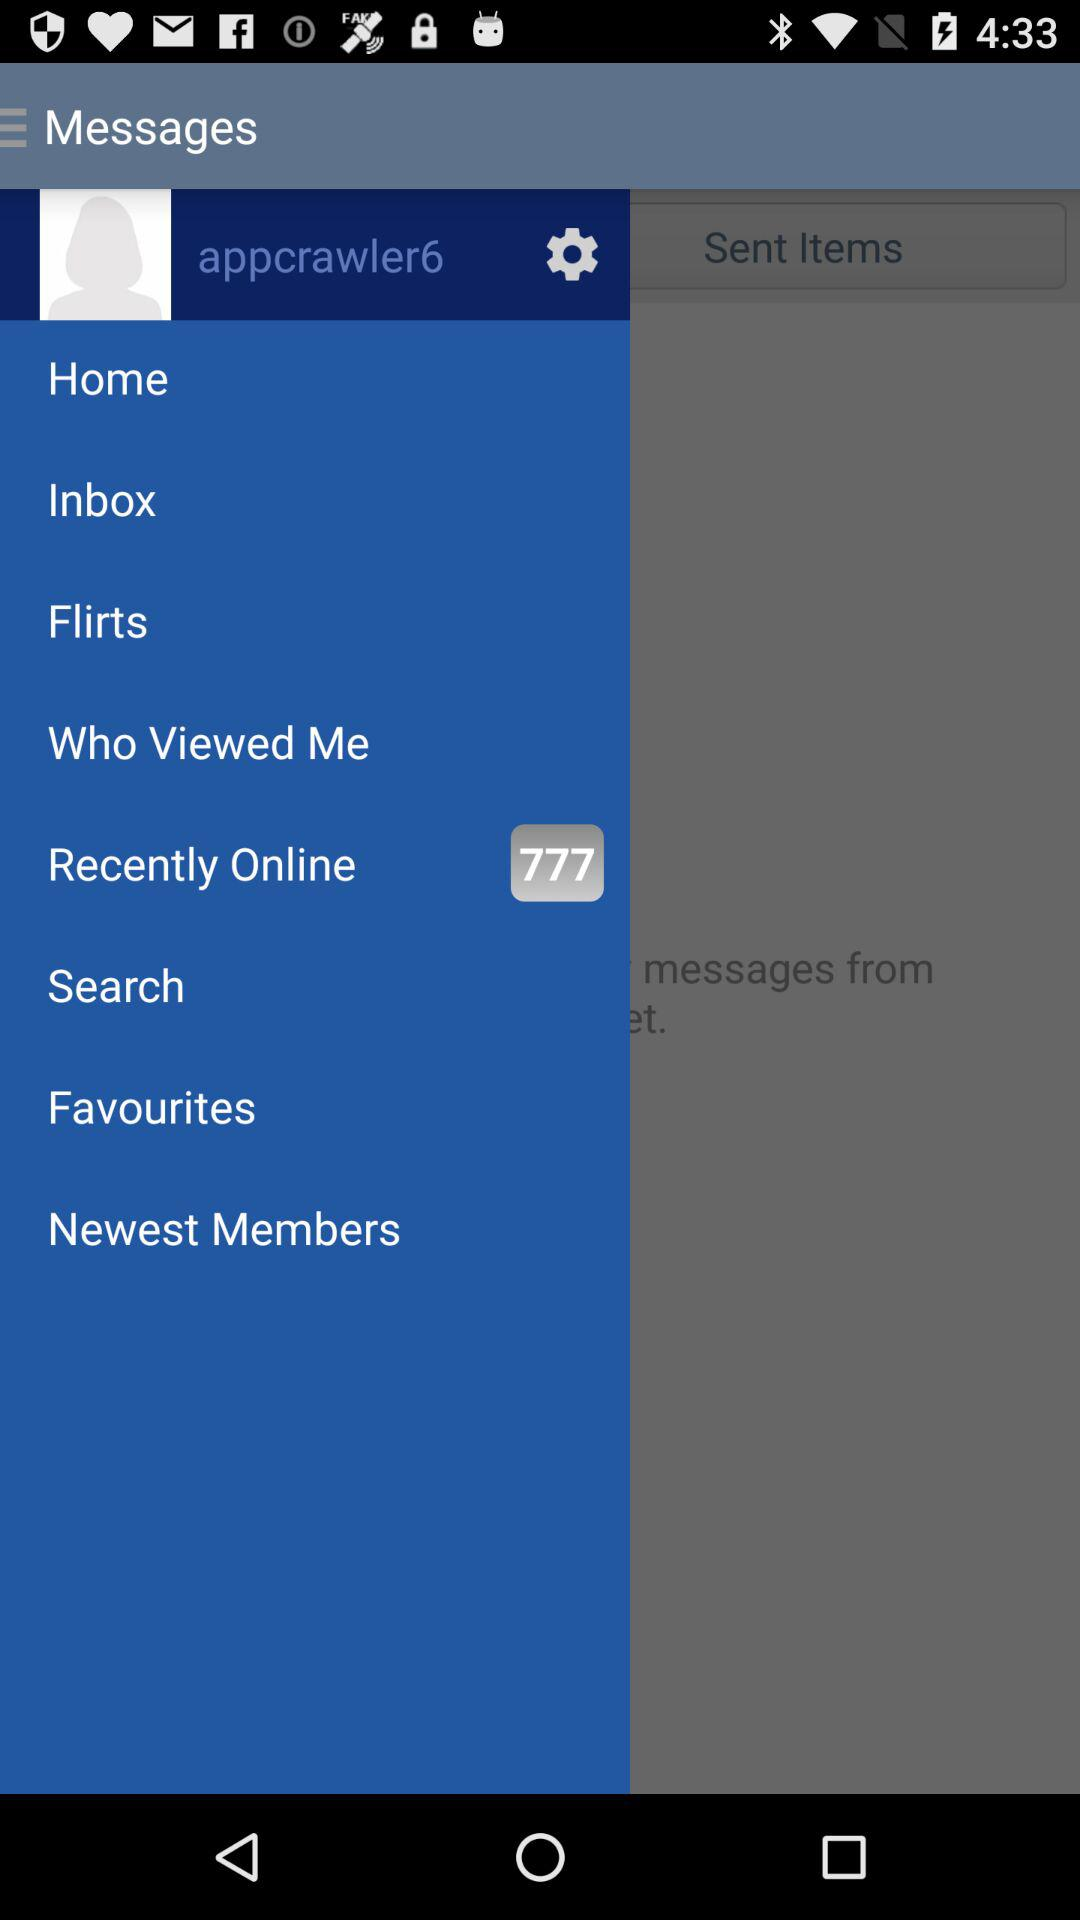What is the username? The username is "appcrawler6". 